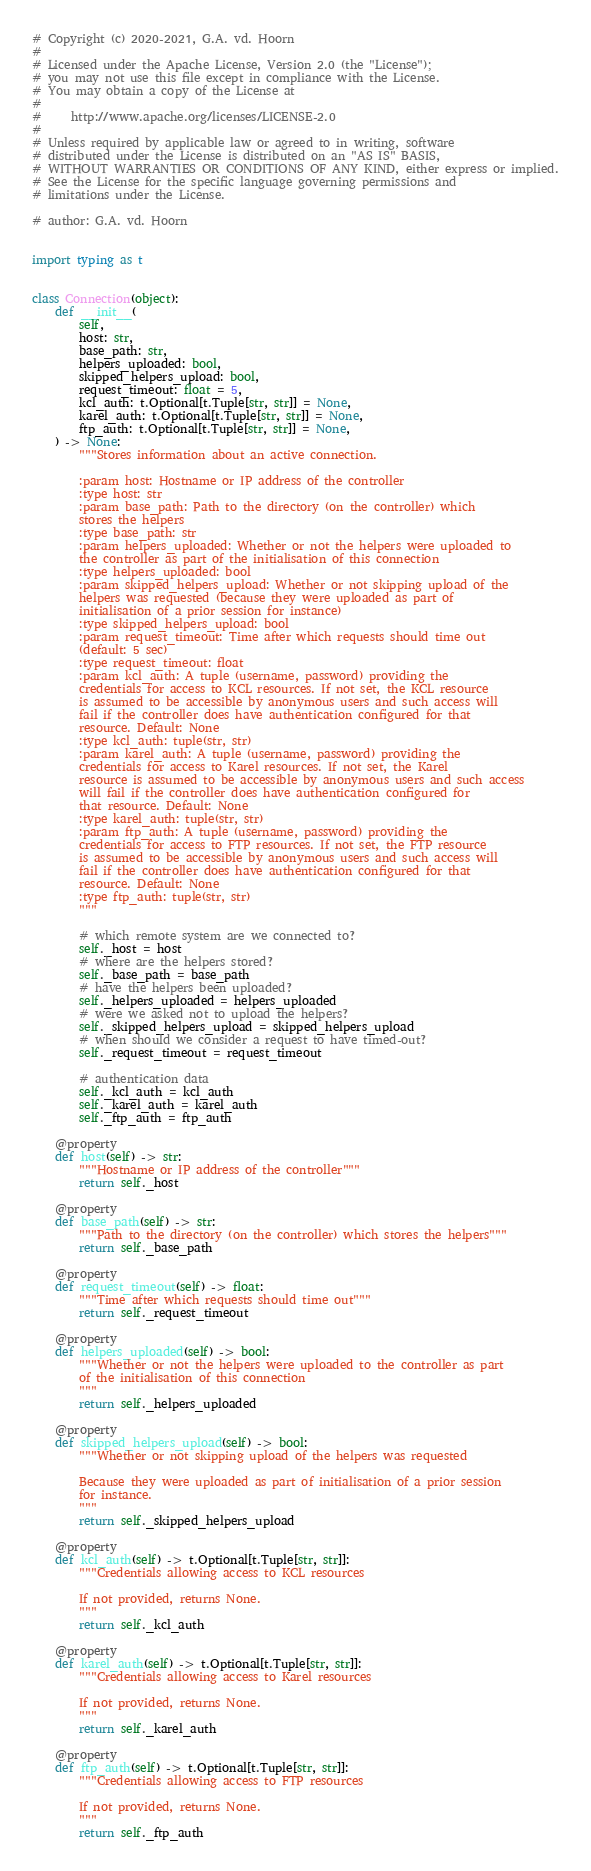Convert code to text. <code><loc_0><loc_0><loc_500><loc_500><_Python_># Copyright (c) 2020-2021, G.A. vd. Hoorn
#
# Licensed under the Apache License, Version 2.0 (the "License");
# you may not use this file except in compliance with the License.
# You may obtain a copy of the License at
#
#     http://www.apache.org/licenses/LICENSE-2.0
#
# Unless required by applicable law or agreed to in writing, software
# distributed under the License is distributed on an "AS IS" BASIS,
# WITHOUT WARRANTIES OR CONDITIONS OF ANY KIND, either express or implied.
# See the License for the specific language governing permissions and
# limitations under the License.

# author: G.A. vd. Hoorn


import typing as t


class Connection(object):
    def __init__(
        self,
        host: str,
        base_path: str,
        helpers_uploaded: bool,
        skipped_helpers_upload: bool,
        request_timeout: float = 5,
        kcl_auth: t.Optional[t.Tuple[str, str]] = None,
        karel_auth: t.Optional[t.Tuple[str, str]] = None,
        ftp_auth: t.Optional[t.Tuple[str, str]] = None,
    ) -> None:
        """Stores information about an active connection.

        :param host: Hostname or IP address of the controller
        :type host: str
        :param base_path: Path to the directory (on the controller) which
        stores the helpers
        :type base_path: str
        :param helpers_uploaded: Whether or not the helpers were uploaded to
        the controller as part of the initialisation of this connection
        :type helpers_uploaded: bool
        :param skipped_helpers_upload: Whether or not skipping upload of the
        helpers was requested (because they were uploaded as part of
        initialisation of a prior session for instance)
        :type skipped_helpers_upload: bool
        :param request_timeout: Time after which requests should time out
        (default: 5 sec)
        :type request_timeout: float
        :param kcl_auth: A tuple (username, password) providing the
        credentials for access to KCL resources. If not set, the KCL resource
        is assumed to be accessible by anonymous users and such access will
        fail if the controller does have authentication configured for that
        resource. Default: None
        :type kcl_auth: tuple(str, str)
        :param karel_auth: A tuple (username, password) providing the
        credentials for access to Karel resources. If not set, the Karel
        resource is assumed to be accessible by anonymous users and such access
        will fail if the controller does have authentication configured for
        that resource. Default: None
        :type karel_auth: tuple(str, str)
        :param ftp_auth: A tuple (username, password) providing the
        credentials for access to FTP resources. If not set, the FTP resource
        is assumed to be accessible by anonymous users and such access will
        fail if the controller does have authentication configured for that
        resource. Default: None
        :type ftp_auth: tuple(str, str)
        """

        # which remote system are we connected to?
        self._host = host
        # where are the helpers stored?
        self._base_path = base_path
        # have the helpers been uploaded?
        self._helpers_uploaded = helpers_uploaded
        # were we asked not to upload the helpers?
        self._skipped_helpers_upload = skipped_helpers_upload
        # when should we consider a request to have timed-out?
        self._request_timeout = request_timeout

        # authentication data
        self._kcl_auth = kcl_auth
        self._karel_auth = karel_auth
        self._ftp_auth = ftp_auth

    @property
    def host(self) -> str:
        """Hostname or IP address of the controller"""
        return self._host

    @property
    def base_path(self) -> str:
        """Path to the directory (on the controller) which stores the helpers"""
        return self._base_path

    @property
    def request_timeout(self) -> float:
        """Time after which requests should time out"""
        return self._request_timeout

    @property
    def helpers_uploaded(self) -> bool:
        """Whether or not the helpers were uploaded to the controller as part
        of the initialisation of this connection
        """
        return self._helpers_uploaded

    @property
    def skipped_helpers_upload(self) -> bool:
        """Whether or not skipping upload of the helpers was requested

        Because they were uploaded as part of initialisation of a prior session
        for instance.
        """
        return self._skipped_helpers_upload

    @property
    def kcl_auth(self) -> t.Optional[t.Tuple[str, str]]:
        """Credentials allowing access to KCL resources

        If not provided, returns None.
        """
        return self._kcl_auth

    @property
    def karel_auth(self) -> t.Optional[t.Tuple[str, str]]:
        """Credentials allowing access to Karel resources

        If not provided, returns None.
        """
        return self._karel_auth

    @property
    def ftp_auth(self) -> t.Optional[t.Tuple[str, str]]:
        """Credentials allowing access to FTP resources

        If not provided, returns None.
        """
        return self._ftp_auth
</code> 